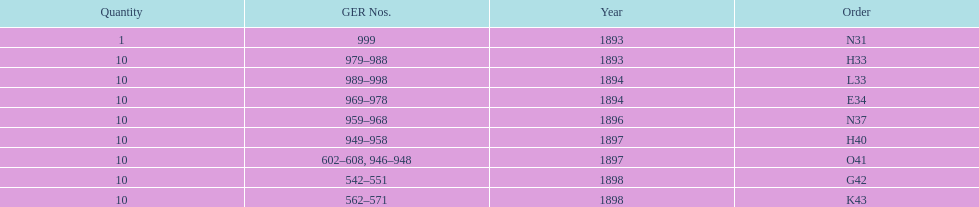How mans years have ger nos below 900? 2. 